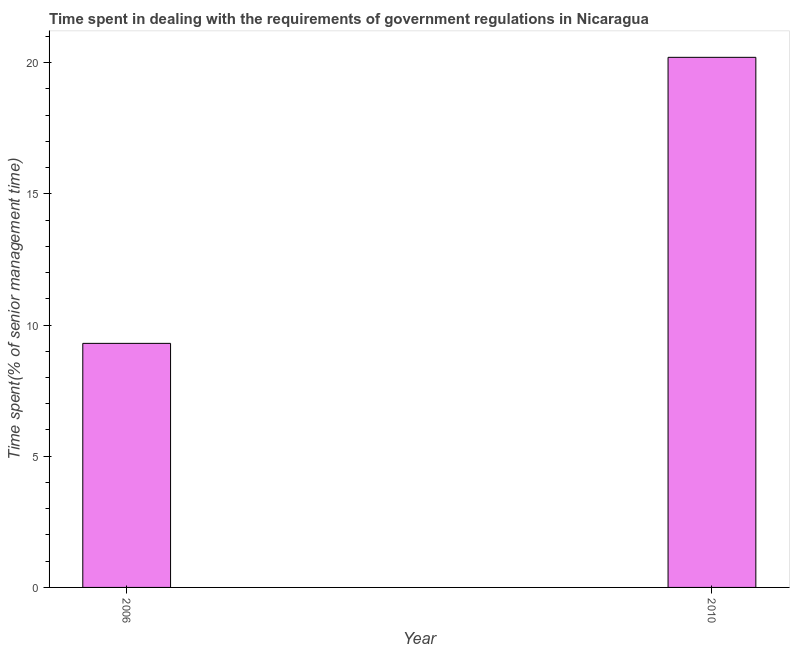What is the title of the graph?
Give a very brief answer. Time spent in dealing with the requirements of government regulations in Nicaragua. What is the label or title of the Y-axis?
Provide a short and direct response. Time spent(% of senior management time). What is the time spent in dealing with government regulations in 2010?
Your response must be concise. 20.2. Across all years, what is the maximum time spent in dealing with government regulations?
Provide a short and direct response. 20.2. In which year was the time spent in dealing with government regulations minimum?
Provide a succinct answer. 2006. What is the sum of the time spent in dealing with government regulations?
Make the answer very short. 29.5. What is the difference between the time spent in dealing with government regulations in 2006 and 2010?
Offer a terse response. -10.9. What is the average time spent in dealing with government regulations per year?
Offer a terse response. 14.75. What is the median time spent in dealing with government regulations?
Give a very brief answer. 14.75. In how many years, is the time spent in dealing with government regulations greater than 2 %?
Provide a succinct answer. 2. What is the ratio of the time spent in dealing with government regulations in 2006 to that in 2010?
Offer a terse response. 0.46. Is the time spent in dealing with government regulations in 2006 less than that in 2010?
Make the answer very short. Yes. How many bars are there?
Your response must be concise. 2. Are all the bars in the graph horizontal?
Your response must be concise. No. How many years are there in the graph?
Provide a short and direct response. 2. What is the Time spent(% of senior management time) in 2006?
Make the answer very short. 9.3. What is the Time spent(% of senior management time) in 2010?
Provide a succinct answer. 20.2. What is the ratio of the Time spent(% of senior management time) in 2006 to that in 2010?
Your response must be concise. 0.46. 